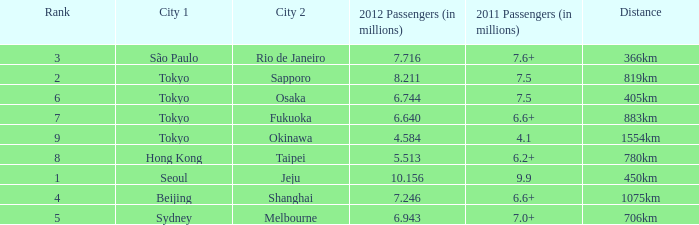How many passengers (in millions) flew from Seoul in 2012? 10.156. 